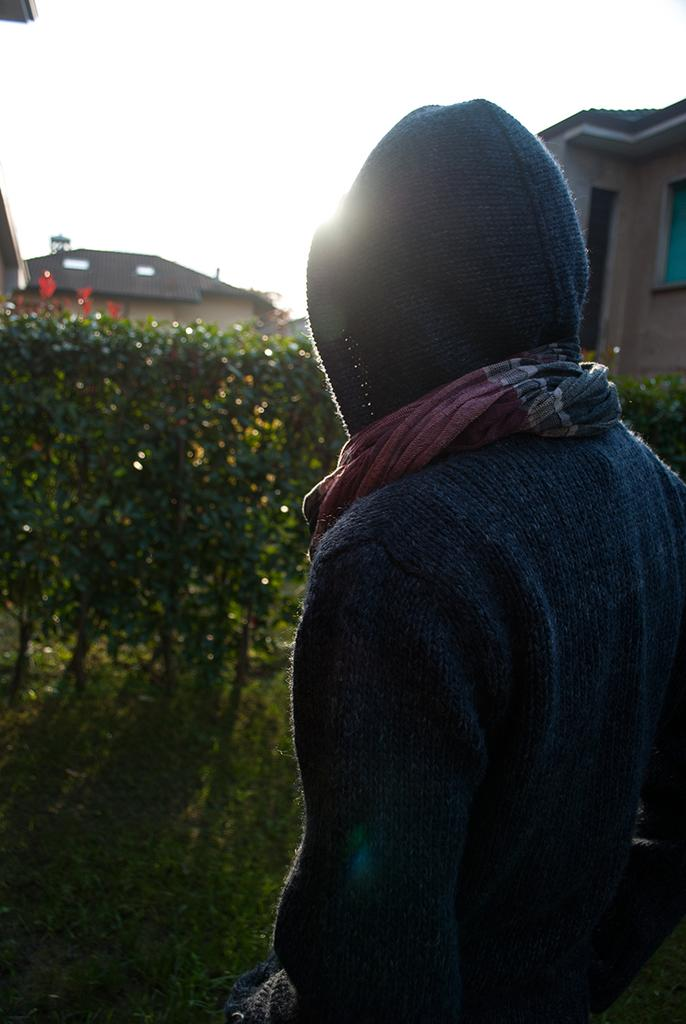What is the person in the image wearing? A: There is a person wearing a jacket in the image. What type of vegetation can be seen in the image? There are plants and grass in the image. What can be seen in the background of the image? There are houses and the sky visible in the background of the image. What color is the deer in the image? There is no deer present in the image. How does the number of plants increase in the image? The number of plants does not increase in the image; the number of plants visible is constant. 